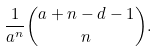<formula> <loc_0><loc_0><loc_500><loc_500>\frac { 1 } { a ^ { n } } \binom { a + n - d - 1 } { n } .</formula> 